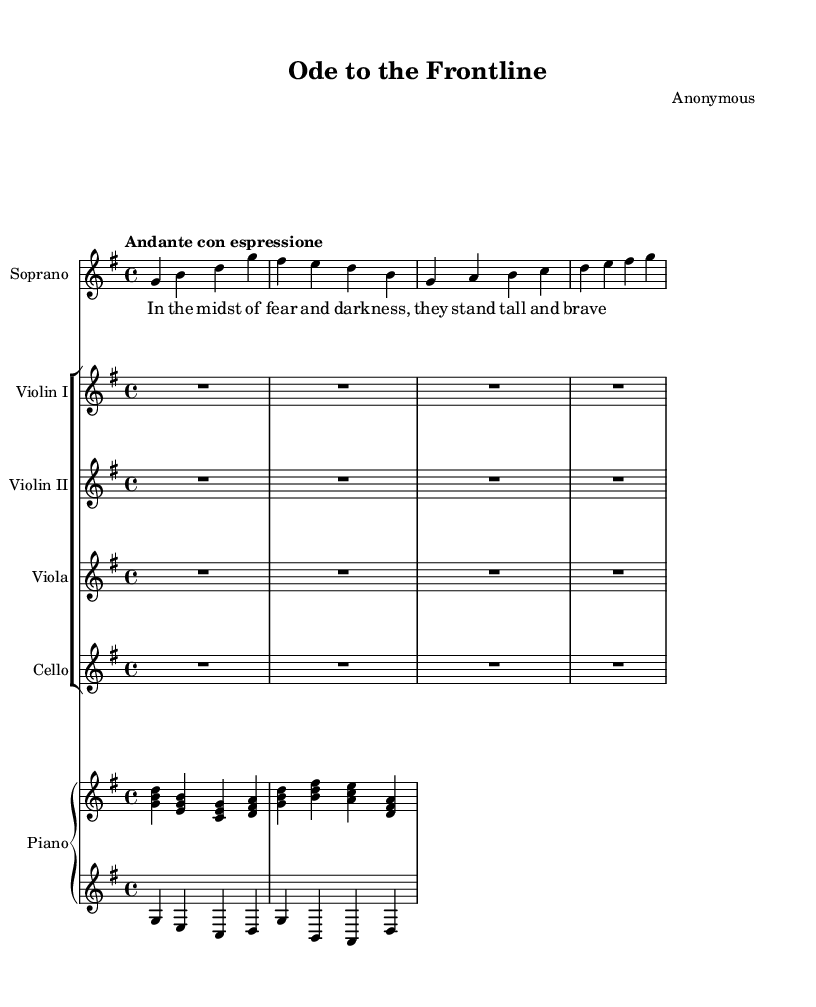What is the key signature of this music? The key signature is G major, which has one sharp, F#. This can be identified by looking at the key signature section at the beginning of the staff.
Answer: G major What is the time signature of the piece? The time signature displayed on the score is 4/4, indicating four beats per measure and a quarter note receiving one beat. This is located at the start of the score near the key signature.
Answer: 4/4 What is the tempo marking for this piece? The tempo marking is "Andante con espressione," which indicates a moderate walking speed with expression. This marking appears at the beginning of the score following the time signature.
Answer: Andante con espressione How many measures are present in the soprano part? The soprano part contains six measures, which can be counted by observing the vertical lines that separate each measure in the staff.
Answer: Six Which instruments are featured in the arrangement? The arrangement includes a soprano, two violins, a viola, a cello, and a piano, as identified by the specific instrument names listed at the beginning of each staff.
Answer: Soprano, Violins I and II, Viola, Cello, Piano What does the lyric in the verse express about healthcare workers? The lyric "In the midst of fear and darkness, they stand tall and brave" highlights the courage and resilience of healthcare workers facing challenges, as can be inferred from the context of the lyrics provided.
Answer: Courage and resilience How is the piano part divided? The piano part is divided into two staves: an upper staff for the right hand and a lower staff for the left hand, this is indicated by the label "upper" and "lower" next to each piano staff.
Answer: Two staves (upper and lower) 